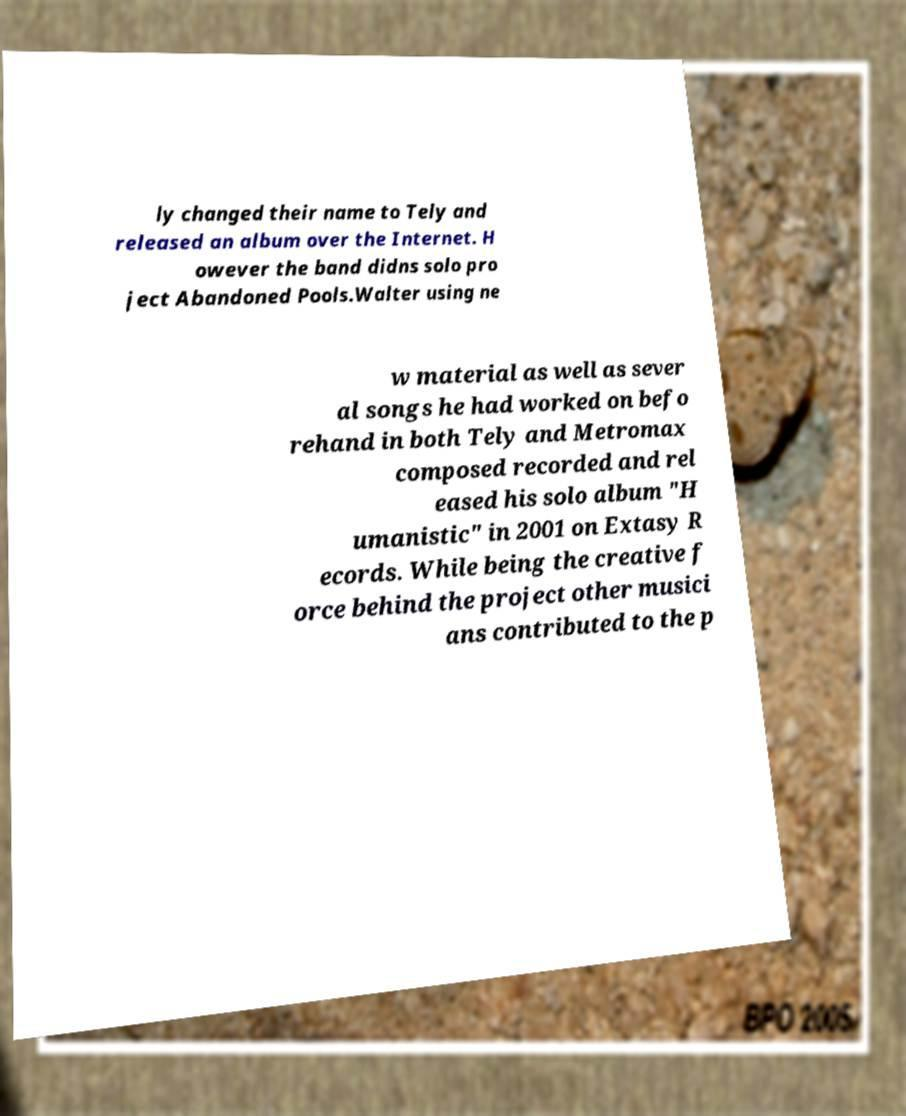For documentation purposes, I need the text within this image transcribed. Could you provide that? ly changed their name to Tely and released an album over the Internet. H owever the band didns solo pro ject Abandoned Pools.Walter using ne w material as well as sever al songs he had worked on befo rehand in both Tely and Metromax composed recorded and rel eased his solo album "H umanistic" in 2001 on Extasy R ecords. While being the creative f orce behind the project other musici ans contributed to the p 